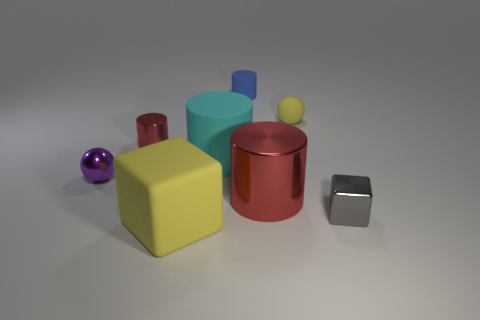Subtract 1 cylinders. How many cylinders are left? 3 Subtract all small red metallic cylinders. How many cylinders are left? 3 Subtract all blue cylinders. How many cylinders are left? 3 Subtract all brown cylinders. Subtract all brown cubes. How many cylinders are left? 4 Add 1 large objects. How many objects exist? 9 Subtract all cubes. How many objects are left? 6 Subtract 1 yellow blocks. How many objects are left? 7 Subtract all brown rubber cylinders. Subtract all cyan cylinders. How many objects are left? 7 Add 7 yellow matte cubes. How many yellow matte cubes are left? 8 Add 7 small red shiny things. How many small red shiny things exist? 8 